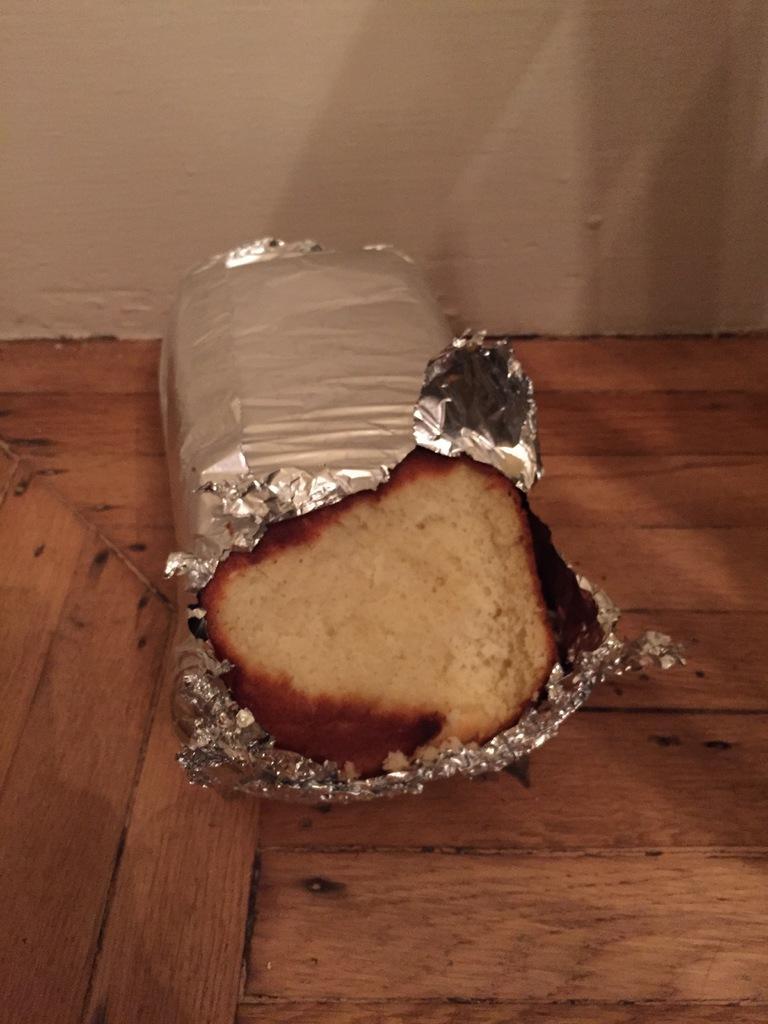Can you describe this image briefly? In this image we can see food item on a wooden platform. In the background there is a wall. 